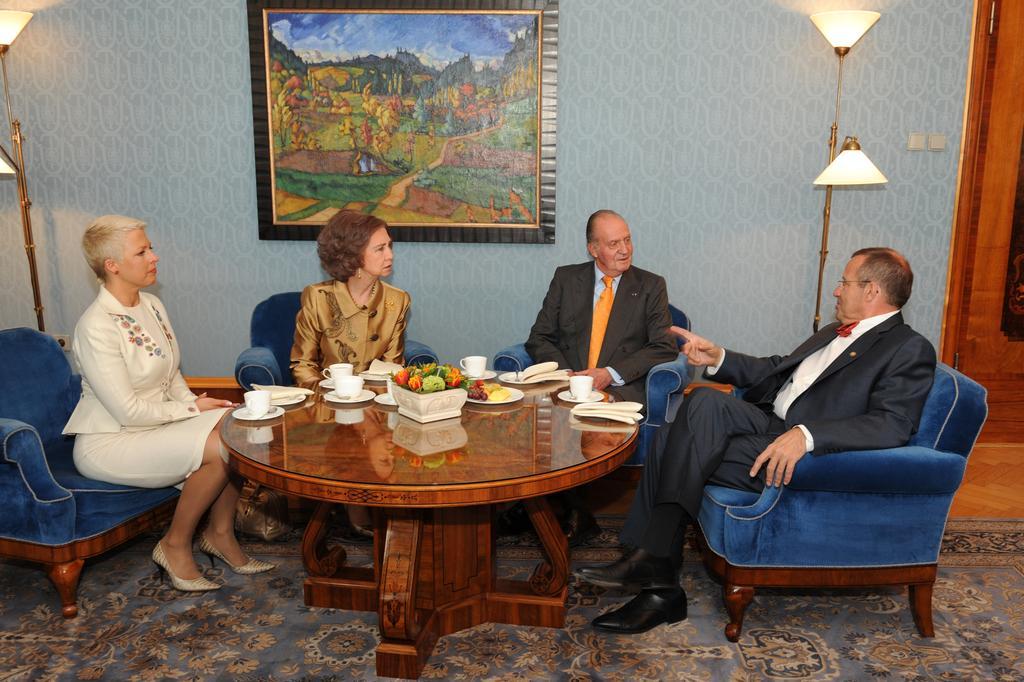In one or two sentences, can you explain what this image depicts? In the picture we can see four people are sitting on the chairs, the chairs are blue in color with wooden under it, two are men and two are women, two men are wearing a blazers, tie, and shirt, before them there is a round table on it we can see a bowl, cup saucers and some food. In the background we can see a wall, lights, and a photo frame with painting in it, and we can also see a floor mat. 